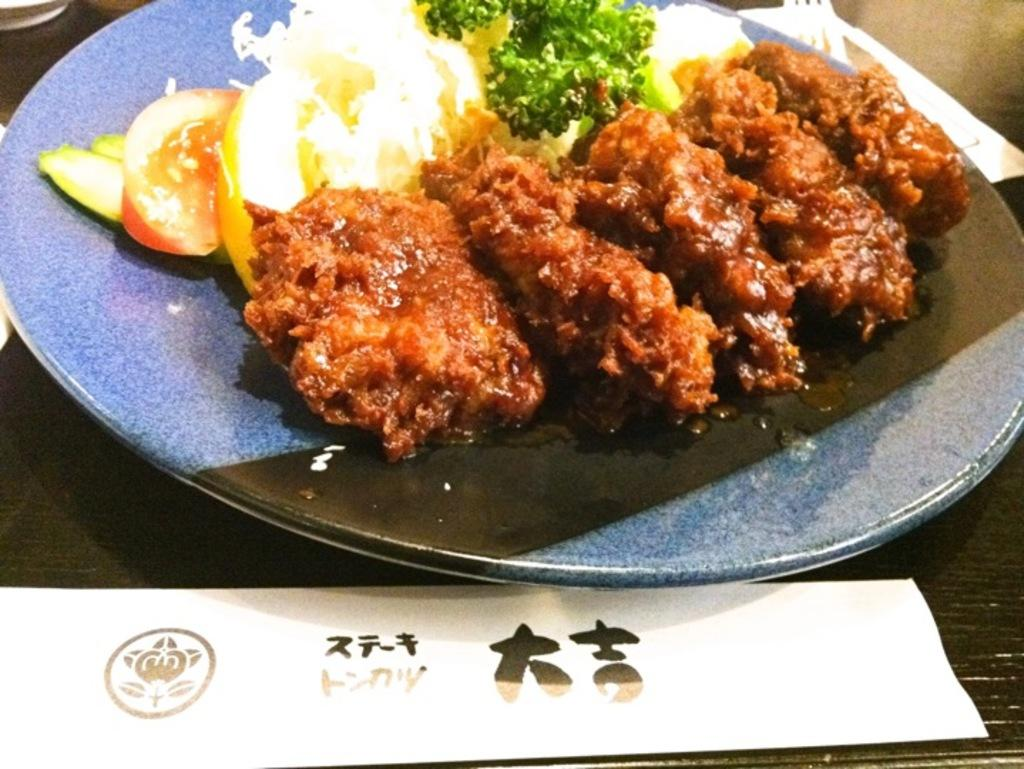What is on the plate that is visible in the image? There are food items on a plate in the image. Where is the plate located in the image? The plate is on a platform. What is written on the paper in the image? There is a text written on a paper in the image. Where is the paper located in the image? The paper is on a platform. What objects are at the top of the platform in the image? There are objects at the top of the platform in the image. What utensil is present on the platform in the image? There is a fork on the platform in the image. What type of skin is visible on the food items in the image? There is no skin visible on the food items in the image. What activity is taking place on the platform in the image? The image does not depict any specific activity taking place on the platform. 